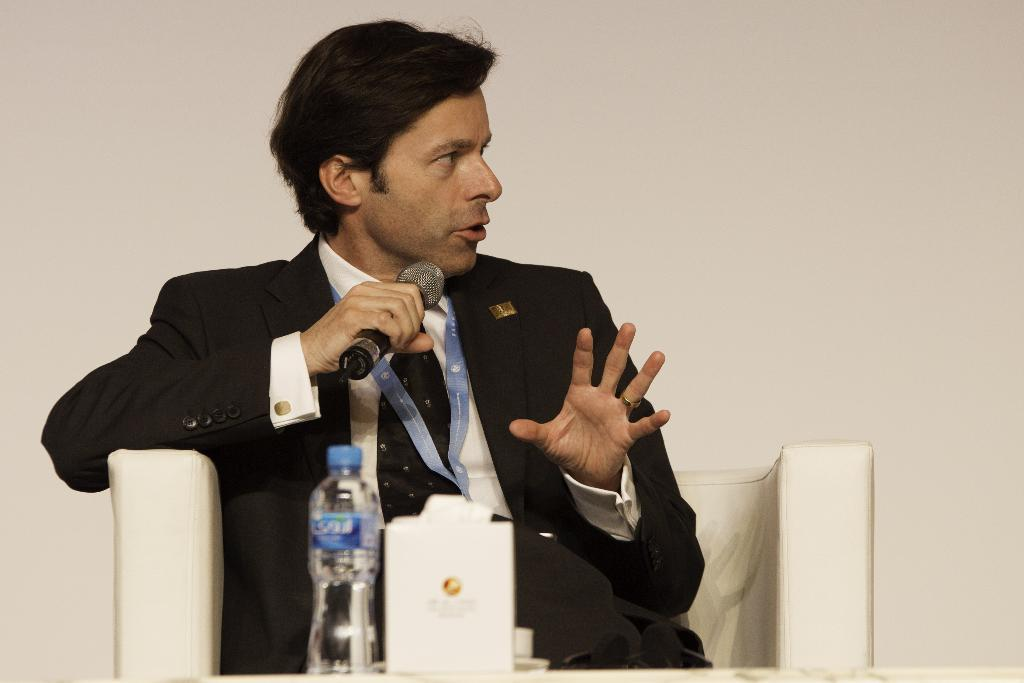What is the man in the image doing? The man is sitting on a chair in the center of the image and holding a microphone. What objects are in front of the man? There is a water bottle and a book in front of the man. What can be seen in the background of the image? There is a wall in the background of the image. What type of glue is being used to hold the industry together in the image? There is no mention of glue, industry, or any related activity in the image. The image features a man sitting on a chair, holding a microphone, with a water bottle and a book in front of him, and a wall in the background. 